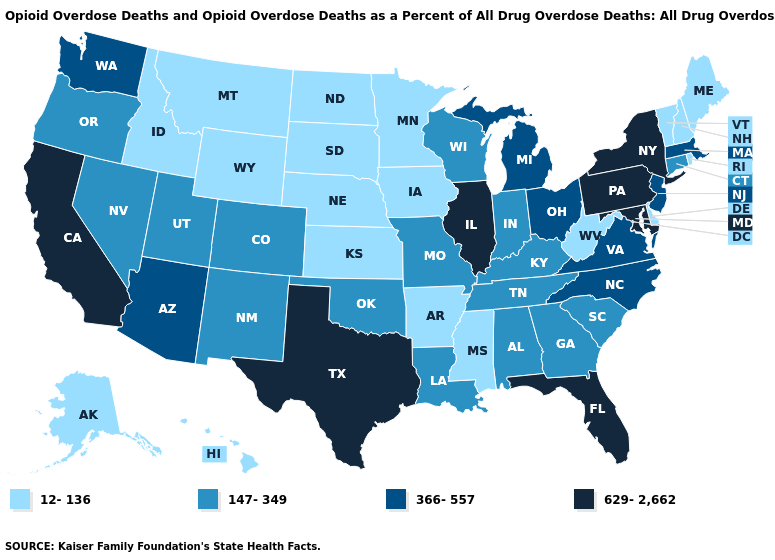Does Tennessee have the same value as Connecticut?
Short answer required. Yes. Which states hav the highest value in the West?
Concise answer only. California. Name the states that have a value in the range 629-2,662?
Answer briefly. California, Florida, Illinois, Maryland, New York, Pennsylvania, Texas. Name the states that have a value in the range 629-2,662?
Be succinct. California, Florida, Illinois, Maryland, New York, Pennsylvania, Texas. Name the states that have a value in the range 12-136?
Write a very short answer. Alaska, Arkansas, Delaware, Hawaii, Idaho, Iowa, Kansas, Maine, Minnesota, Mississippi, Montana, Nebraska, New Hampshire, North Dakota, Rhode Island, South Dakota, Vermont, West Virginia, Wyoming. Name the states that have a value in the range 366-557?
Keep it brief. Arizona, Massachusetts, Michigan, New Jersey, North Carolina, Ohio, Virginia, Washington. Name the states that have a value in the range 12-136?
Concise answer only. Alaska, Arkansas, Delaware, Hawaii, Idaho, Iowa, Kansas, Maine, Minnesota, Mississippi, Montana, Nebraska, New Hampshire, North Dakota, Rhode Island, South Dakota, Vermont, West Virginia, Wyoming. Among the states that border Kentucky , does Illinois have the highest value?
Keep it brief. Yes. Name the states that have a value in the range 629-2,662?
Give a very brief answer. California, Florida, Illinois, Maryland, New York, Pennsylvania, Texas. What is the value of South Dakota?
Short answer required. 12-136. Which states have the lowest value in the Northeast?
Quick response, please. Maine, New Hampshire, Rhode Island, Vermont. Among the states that border Wyoming , which have the highest value?
Short answer required. Colorado, Utah. What is the value of New Mexico?
Answer briefly. 147-349. Name the states that have a value in the range 366-557?
Concise answer only. Arizona, Massachusetts, Michigan, New Jersey, North Carolina, Ohio, Virginia, Washington. 